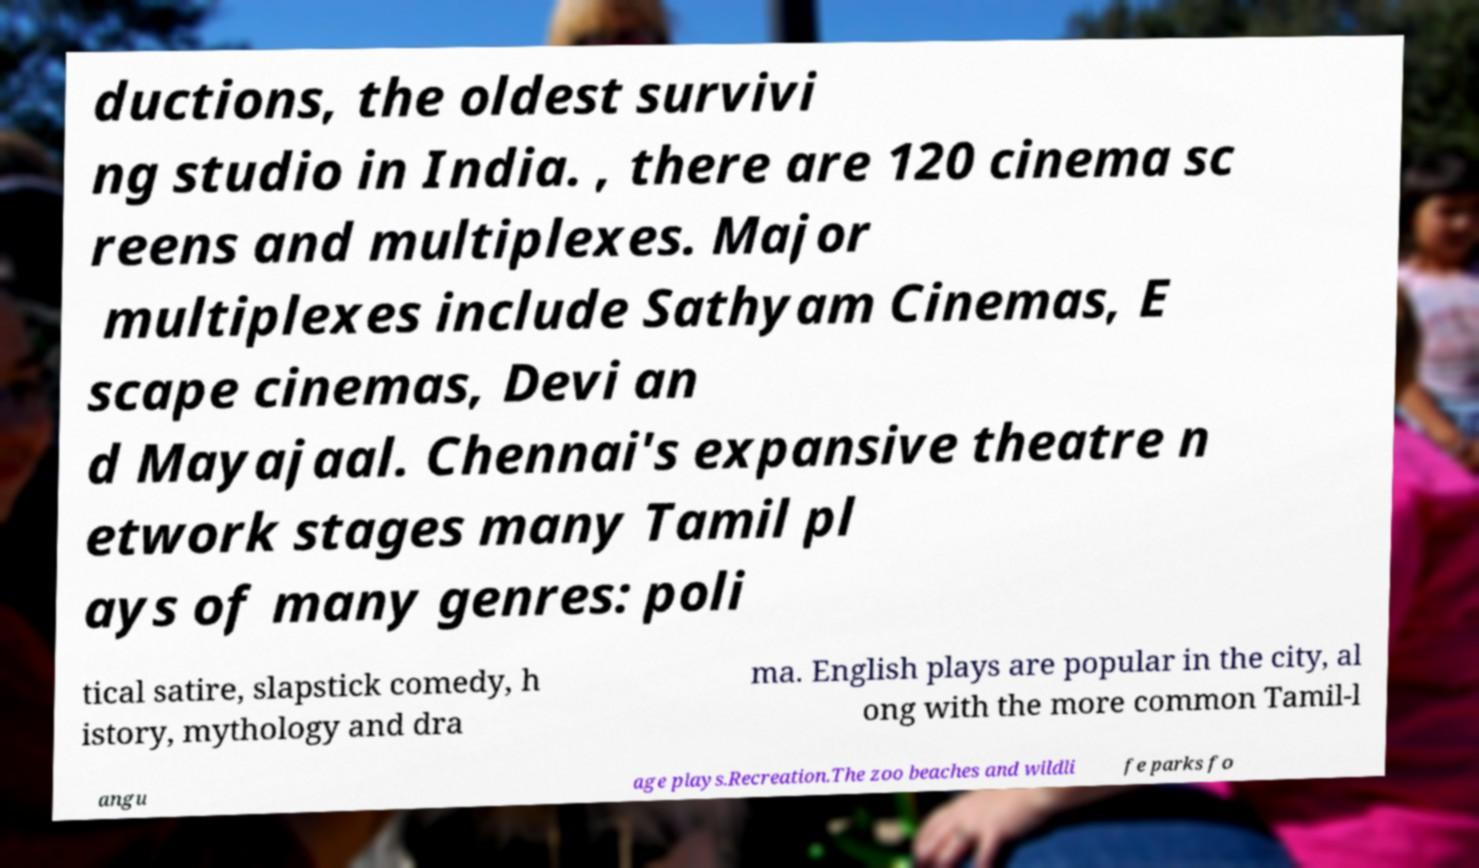What messages or text are displayed in this image? I need them in a readable, typed format. ductions, the oldest survivi ng studio in India. , there are 120 cinema sc reens and multiplexes. Major multiplexes include Sathyam Cinemas, E scape cinemas, Devi an d Mayajaal. Chennai's expansive theatre n etwork stages many Tamil pl ays of many genres: poli tical satire, slapstick comedy, h istory, mythology and dra ma. English plays are popular in the city, al ong with the more common Tamil-l angu age plays.Recreation.The zoo beaches and wildli fe parks fo 